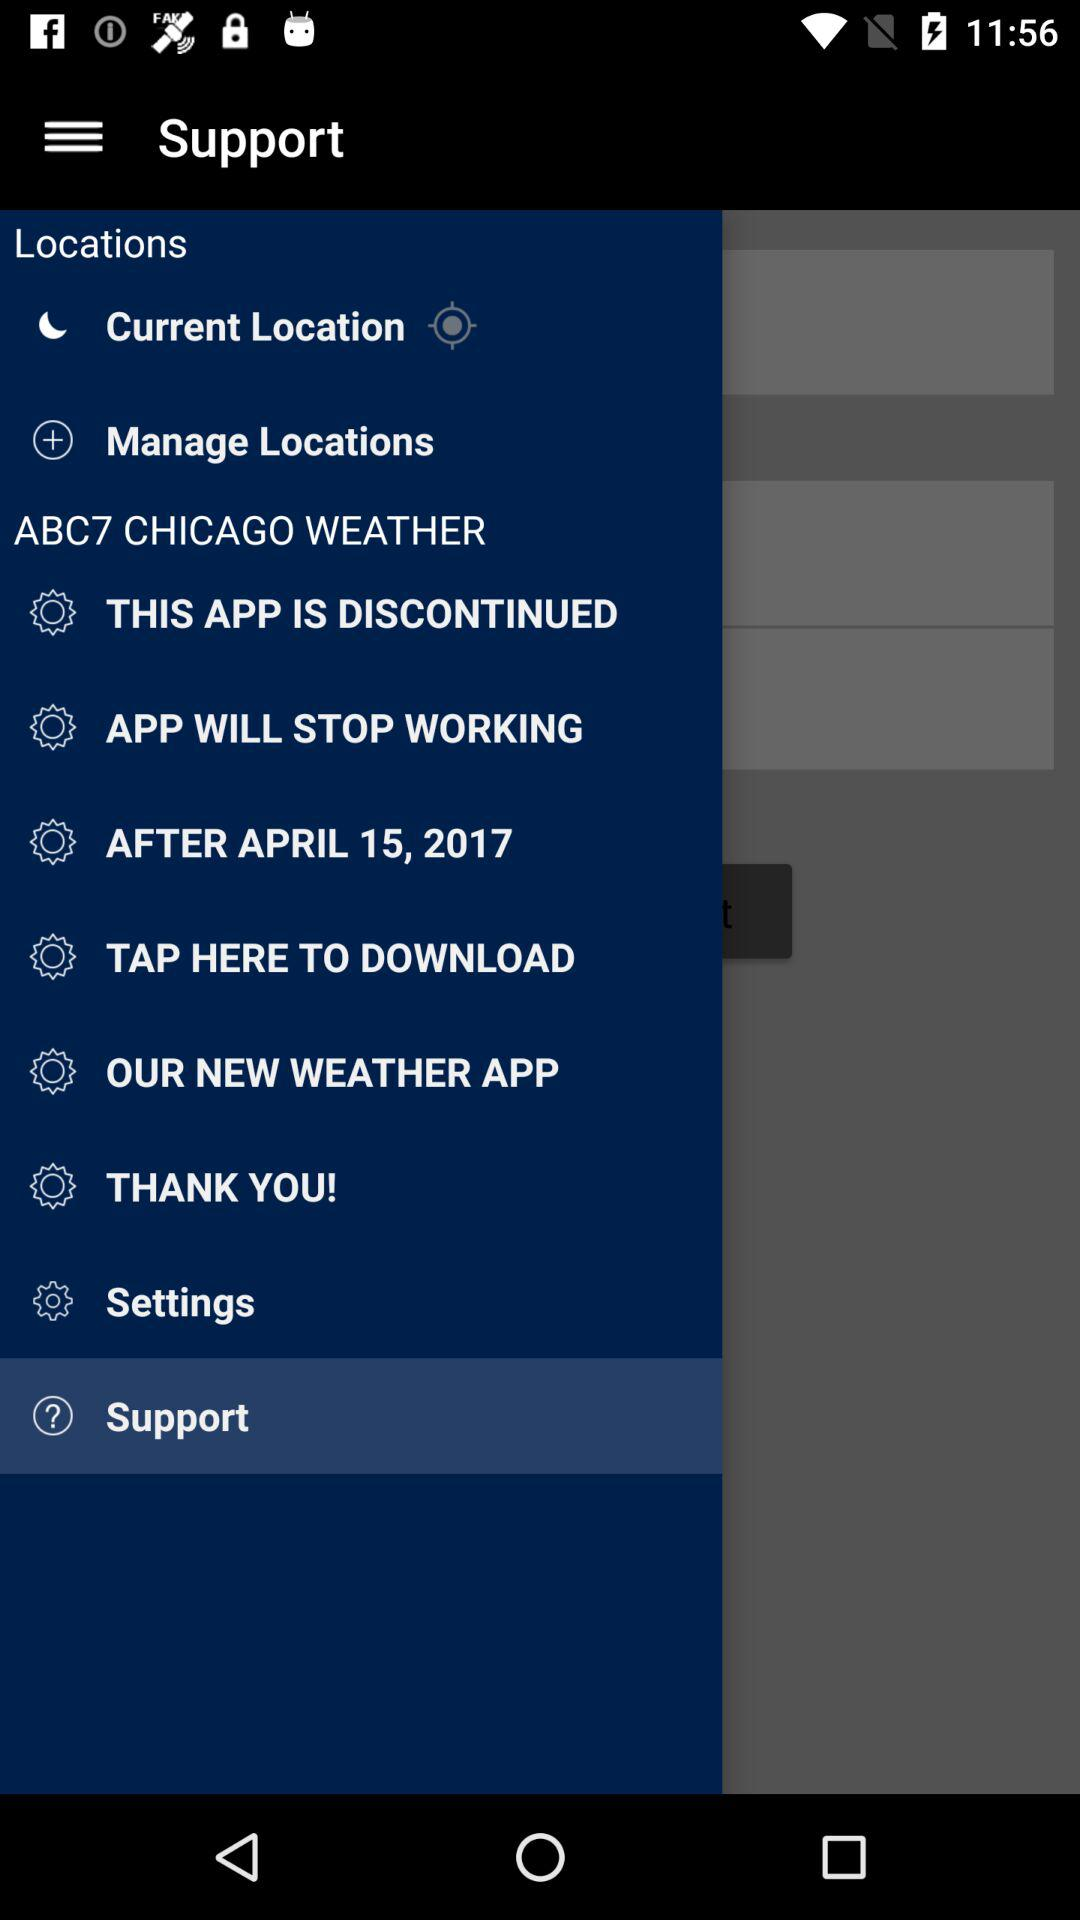What is the name of the application? The name of the application is "ABC7 CHICAGO WEATHER". 